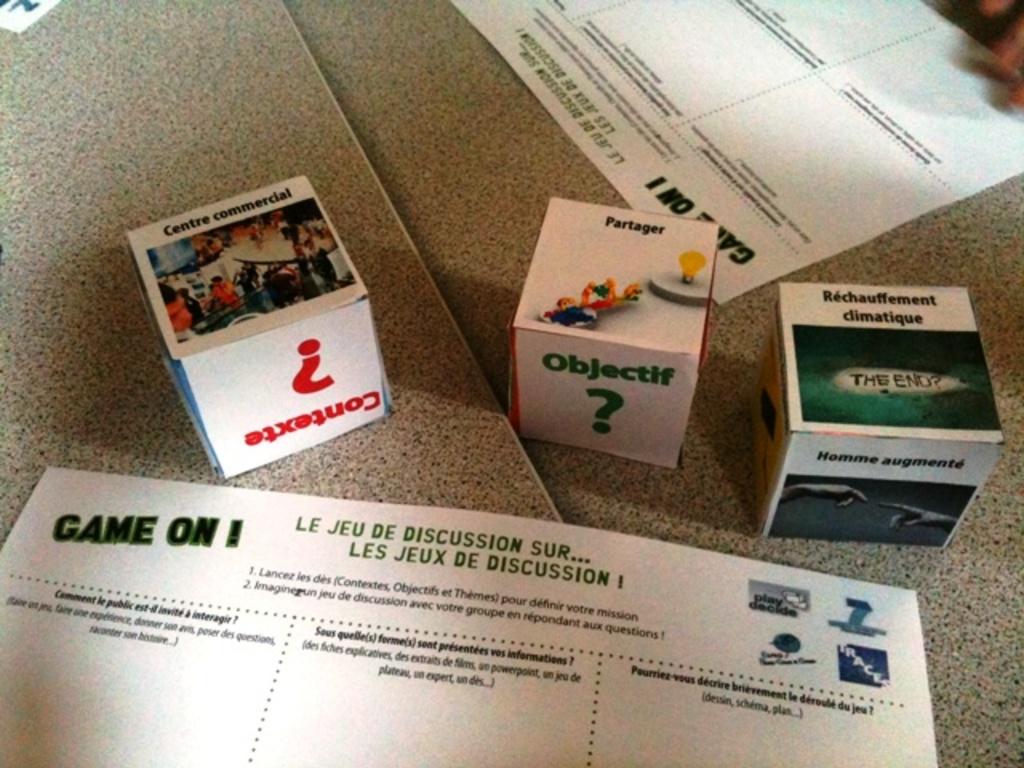What does the middle box say?
Give a very brief answer. Objectif. What does the box say on the side?
Give a very brief answer. Objectif. 